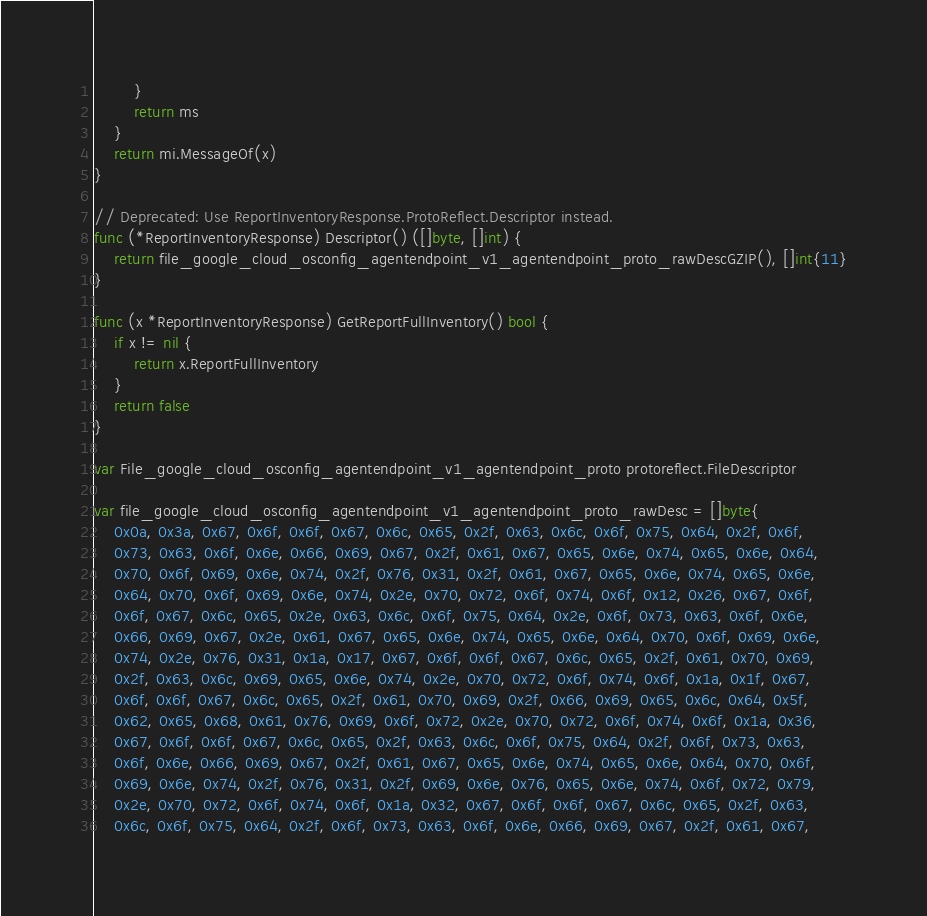Convert code to text. <code><loc_0><loc_0><loc_500><loc_500><_Go_>		}
		return ms
	}
	return mi.MessageOf(x)
}

// Deprecated: Use ReportInventoryResponse.ProtoReflect.Descriptor instead.
func (*ReportInventoryResponse) Descriptor() ([]byte, []int) {
	return file_google_cloud_osconfig_agentendpoint_v1_agentendpoint_proto_rawDescGZIP(), []int{11}
}

func (x *ReportInventoryResponse) GetReportFullInventory() bool {
	if x != nil {
		return x.ReportFullInventory
	}
	return false
}

var File_google_cloud_osconfig_agentendpoint_v1_agentendpoint_proto protoreflect.FileDescriptor

var file_google_cloud_osconfig_agentendpoint_v1_agentendpoint_proto_rawDesc = []byte{
	0x0a, 0x3a, 0x67, 0x6f, 0x6f, 0x67, 0x6c, 0x65, 0x2f, 0x63, 0x6c, 0x6f, 0x75, 0x64, 0x2f, 0x6f,
	0x73, 0x63, 0x6f, 0x6e, 0x66, 0x69, 0x67, 0x2f, 0x61, 0x67, 0x65, 0x6e, 0x74, 0x65, 0x6e, 0x64,
	0x70, 0x6f, 0x69, 0x6e, 0x74, 0x2f, 0x76, 0x31, 0x2f, 0x61, 0x67, 0x65, 0x6e, 0x74, 0x65, 0x6e,
	0x64, 0x70, 0x6f, 0x69, 0x6e, 0x74, 0x2e, 0x70, 0x72, 0x6f, 0x74, 0x6f, 0x12, 0x26, 0x67, 0x6f,
	0x6f, 0x67, 0x6c, 0x65, 0x2e, 0x63, 0x6c, 0x6f, 0x75, 0x64, 0x2e, 0x6f, 0x73, 0x63, 0x6f, 0x6e,
	0x66, 0x69, 0x67, 0x2e, 0x61, 0x67, 0x65, 0x6e, 0x74, 0x65, 0x6e, 0x64, 0x70, 0x6f, 0x69, 0x6e,
	0x74, 0x2e, 0x76, 0x31, 0x1a, 0x17, 0x67, 0x6f, 0x6f, 0x67, 0x6c, 0x65, 0x2f, 0x61, 0x70, 0x69,
	0x2f, 0x63, 0x6c, 0x69, 0x65, 0x6e, 0x74, 0x2e, 0x70, 0x72, 0x6f, 0x74, 0x6f, 0x1a, 0x1f, 0x67,
	0x6f, 0x6f, 0x67, 0x6c, 0x65, 0x2f, 0x61, 0x70, 0x69, 0x2f, 0x66, 0x69, 0x65, 0x6c, 0x64, 0x5f,
	0x62, 0x65, 0x68, 0x61, 0x76, 0x69, 0x6f, 0x72, 0x2e, 0x70, 0x72, 0x6f, 0x74, 0x6f, 0x1a, 0x36,
	0x67, 0x6f, 0x6f, 0x67, 0x6c, 0x65, 0x2f, 0x63, 0x6c, 0x6f, 0x75, 0x64, 0x2f, 0x6f, 0x73, 0x63,
	0x6f, 0x6e, 0x66, 0x69, 0x67, 0x2f, 0x61, 0x67, 0x65, 0x6e, 0x74, 0x65, 0x6e, 0x64, 0x70, 0x6f,
	0x69, 0x6e, 0x74, 0x2f, 0x76, 0x31, 0x2f, 0x69, 0x6e, 0x76, 0x65, 0x6e, 0x74, 0x6f, 0x72, 0x79,
	0x2e, 0x70, 0x72, 0x6f, 0x74, 0x6f, 0x1a, 0x32, 0x67, 0x6f, 0x6f, 0x67, 0x6c, 0x65, 0x2f, 0x63,
	0x6c, 0x6f, 0x75, 0x64, 0x2f, 0x6f, 0x73, 0x63, 0x6f, 0x6e, 0x66, 0x69, 0x67, 0x2f, 0x61, 0x67,</code> 